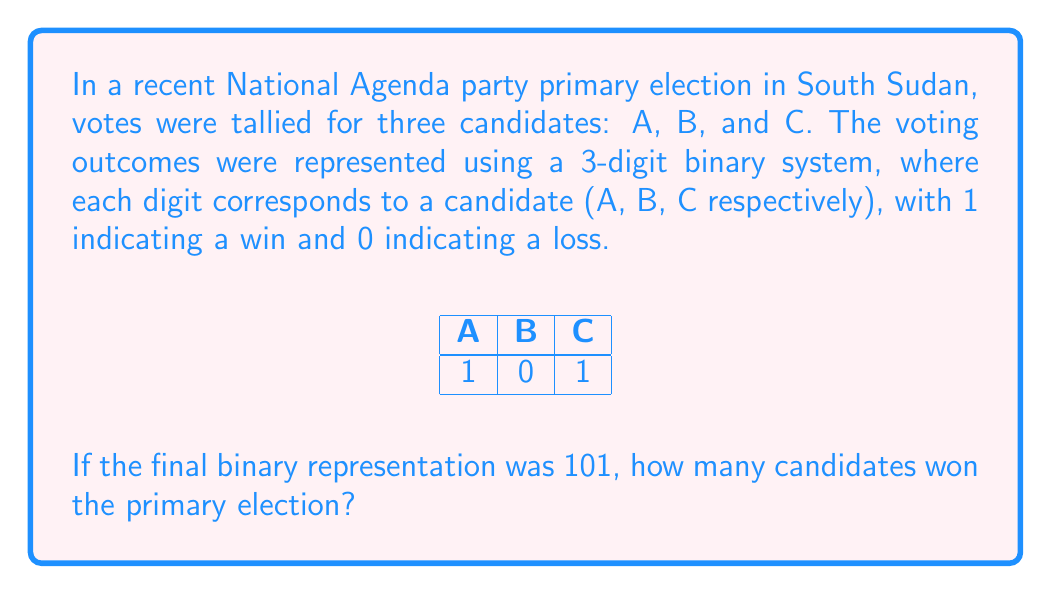Give your solution to this math problem. Let's break this down step-by-step:

1) In binary, each digit represents a power of 2. In this case, we're using a 3-digit binary number to represent the election outcome.

2) The given binary number is 101. In a 3-digit binary system:
   - The leftmost digit represents $2^2 = 4$
   - The middle digit represents $2^1 = 2$
   - The rightmost digit represents $2^0 = 1$

3) In our election scenario:
   - The leftmost digit (1) represents candidate A
   - The middle digit (0) represents candidate B
   - The rightmost digit (1) represents candidate C

4) Interpreting the binary number 101:
   - A (leftmost): 1 = win
   - B (middle): 0 = loss
   - C (rightmost): 1 = win

5) Counting the number of 1's in the binary representation gives us the number of winning candidates.

6) There are two 1's in 101, corresponding to candidates A and C.

Therefore, 2 candidates won the primary election.
Answer: 2 